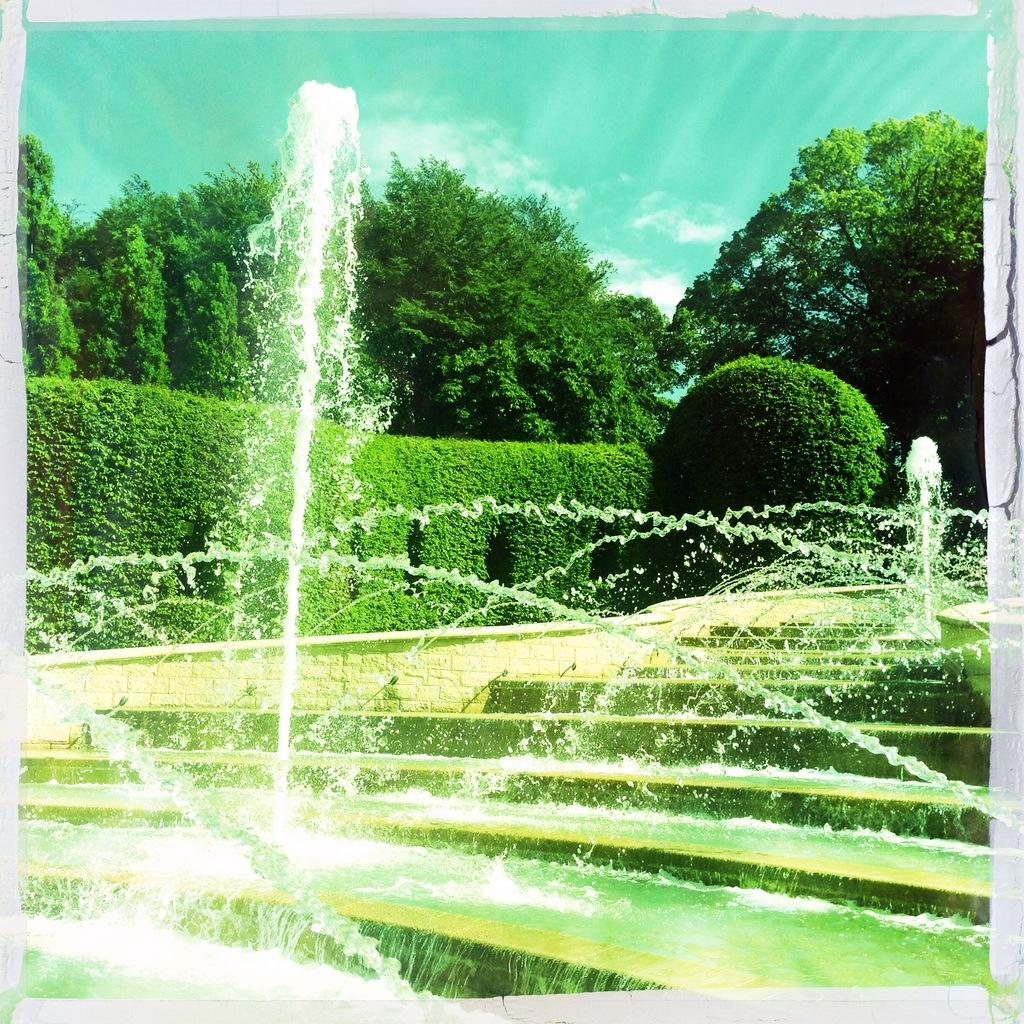What type of natural formation can be seen in the image? There are mountains in the image. What type of vegetation is visible in the background of the image? There are plants, trees, and grass in the background of the image. What is visible at the top of the image? The sky is visible at the top of the image. What can be seen in the sky in the image? Clouds are present in the sky. Can you find the key that was smashed by the rest of the group in the image? There is no key or any indication of a group smashing a key in the image. 